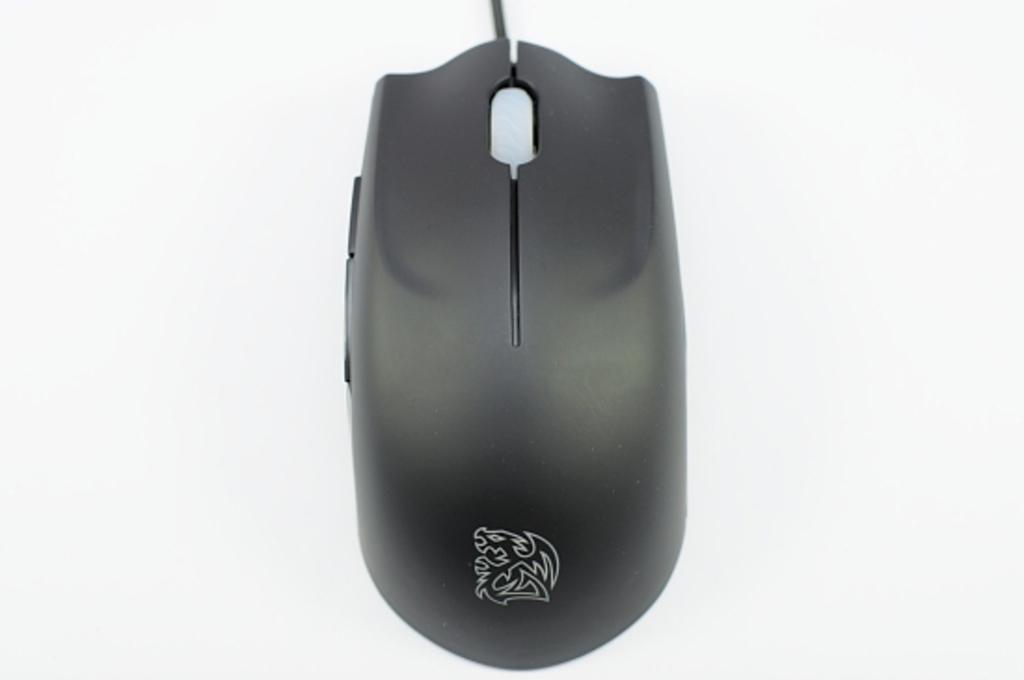What type of animal is in the image? There is a mouse in the image. Where is the mouse located in the image? The mouse is placed on a surface. How many sisters does the mouse have in the image? There is no information about the mouse's sisters in the image, as it only shows a mouse placed on a surface. 